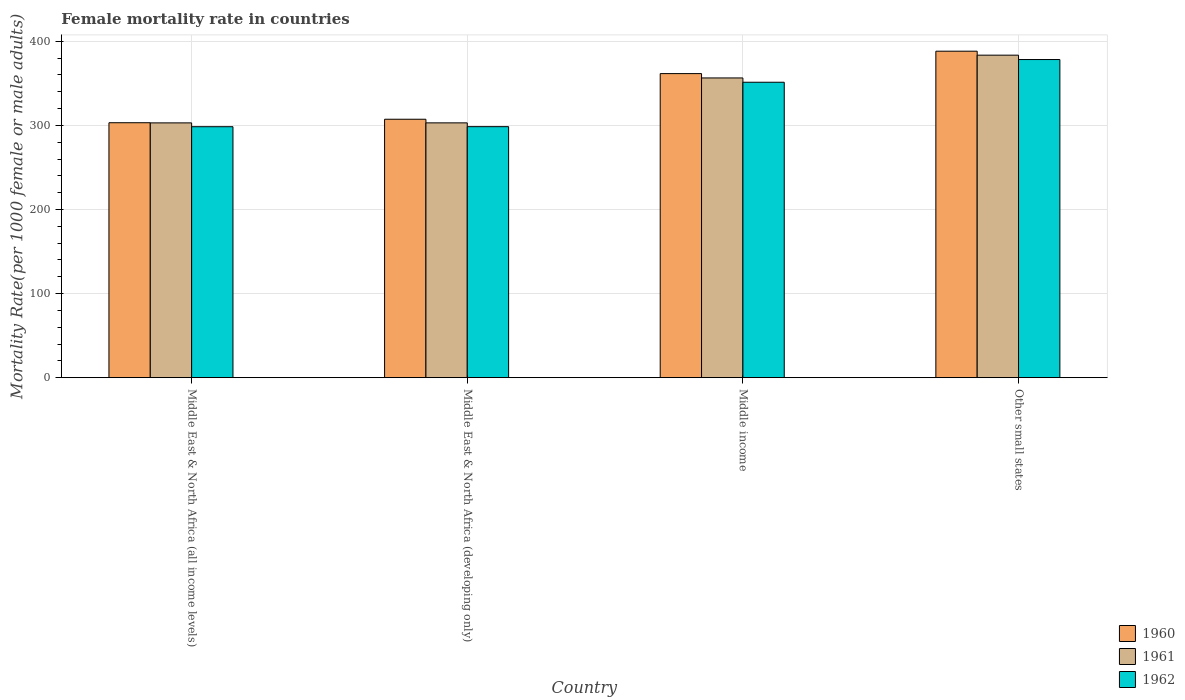How many different coloured bars are there?
Ensure brevity in your answer.  3. Are the number of bars on each tick of the X-axis equal?
Your answer should be very brief. Yes. How many bars are there on the 1st tick from the right?
Provide a short and direct response. 3. What is the label of the 3rd group of bars from the left?
Provide a succinct answer. Middle income. What is the female mortality rate in 1961 in Middle East & North Africa (developing only)?
Make the answer very short. 302.99. Across all countries, what is the maximum female mortality rate in 1961?
Keep it short and to the point. 383.48. Across all countries, what is the minimum female mortality rate in 1960?
Give a very brief answer. 303.15. In which country was the female mortality rate in 1960 maximum?
Your answer should be compact. Other small states. In which country was the female mortality rate in 1960 minimum?
Offer a very short reply. Middle East & North Africa (all income levels). What is the total female mortality rate in 1960 in the graph?
Ensure brevity in your answer.  1360.19. What is the difference between the female mortality rate in 1960 in Middle East & North Africa (developing only) and that in Other small states?
Offer a terse response. -80.92. What is the difference between the female mortality rate in 1961 in Middle income and the female mortality rate in 1962 in Other small states?
Ensure brevity in your answer.  -21.89. What is the average female mortality rate in 1961 per country?
Your answer should be compact. 336.46. What is the difference between the female mortality rate of/in 1961 and female mortality rate of/in 1960 in Middle East & North Africa (developing only)?
Make the answer very short. -4.3. What is the ratio of the female mortality rate in 1960 in Middle East & North Africa (all income levels) to that in Other small states?
Your answer should be compact. 0.78. Is the female mortality rate in 1962 in Middle East & North Africa (developing only) less than that in Other small states?
Your answer should be very brief. Yes. Is the difference between the female mortality rate in 1961 in Middle East & North Africa (developing only) and Other small states greater than the difference between the female mortality rate in 1960 in Middle East & North Africa (developing only) and Other small states?
Ensure brevity in your answer.  Yes. What is the difference between the highest and the second highest female mortality rate in 1961?
Provide a short and direct response. 53.41. What is the difference between the highest and the lowest female mortality rate in 1961?
Give a very brief answer. 80.53. Is the sum of the female mortality rate in 1961 in Middle East & North Africa (developing only) and Middle income greater than the maximum female mortality rate in 1960 across all countries?
Offer a very short reply. Yes. What does the 3rd bar from the right in Middle income represents?
Your answer should be compact. 1960. Is it the case that in every country, the sum of the female mortality rate in 1962 and female mortality rate in 1961 is greater than the female mortality rate in 1960?
Ensure brevity in your answer.  Yes. What is the difference between two consecutive major ticks on the Y-axis?
Keep it short and to the point. 100. Does the graph contain any zero values?
Offer a terse response. No. Where does the legend appear in the graph?
Ensure brevity in your answer.  Bottom right. How are the legend labels stacked?
Ensure brevity in your answer.  Vertical. What is the title of the graph?
Your response must be concise. Female mortality rate in countries. What is the label or title of the X-axis?
Make the answer very short. Country. What is the label or title of the Y-axis?
Make the answer very short. Mortality Rate(per 1000 female or male adults). What is the Mortality Rate(per 1000 female or male adults) of 1960 in Middle East & North Africa (all income levels)?
Make the answer very short. 303.15. What is the Mortality Rate(per 1000 female or male adults) in 1961 in Middle East & North Africa (all income levels)?
Your response must be concise. 302.95. What is the Mortality Rate(per 1000 female or male adults) in 1962 in Middle East & North Africa (all income levels)?
Your response must be concise. 298.42. What is the Mortality Rate(per 1000 female or male adults) of 1960 in Middle East & North Africa (developing only)?
Ensure brevity in your answer.  307.28. What is the Mortality Rate(per 1000 female or male adults) in 1961 in Middle East & North Africa (developing only)?
Ensure brevity in your answer.  302.99. What is the Mortality Rate(per 1000 female or male adults) of 1962 in Middle East & North Africa (developing only)?
Your response must be concise. 298.47. What is the Mortality Rate(per 1000 female or male adults) in 1960 in Middle income?
Your answer should be very brief. 361.56. What is the Mortality Rate(per 1000 female or male adults) in 1961 in Middle income?
Give a very brief answer. 356.4. What is the Mortality Rate(per 1000 female or male adults) in 1962 in Middle income?
Keep it short and to the point. 351.28. What is the Mortality Rate(per 1000 female or male adults) of 1960 in Other small states?
Give a very brief answer. 388.2. What is the Mortality Rate(per 1000 female or male adults) of 1961 in Other small states?
Ensure brevity in your answer.  383.48. What is the Mortality Rate(per 1000 female or male adults) in 1962 in Other small states?
Offer a terse response. 378.29. Across all countries, what is the maximum Mortality Rate(per 1000 female or male adults) of 1960?
Your answer should be compact. 388.2. Across all countries, what is the maximum Mortality Rate(per 1000 female or male adults) in 1961?
Offer a very short reply. 383.48. Across all countries, what is the maximum Mortality Rate(per 1000 female or male adults) in 1962?
Offer a terse response. 378.29. Across all countries, what is the minimum Mortality Rate(per 1000 female or male adults) in 1960?
Ensure brevity in your answer.  303.15. Across all countries, what is the minimum Mortality Rate(per 1000 female or male adults) in 1961?
Your response must be concise. 302.95. Across all countries, what is the minimum Mortality Rate(per 1000 female or male adults) in 1962?
Your answer should be compact. 298.42. What is the total Mortality Rate(per 1000 female or male adults) of 1960 in the graph?
Ensure brevity in your answer.  1360.19. What is the total Mortality Rate(per 1000 female or male adults) in 1961 in the graph?
Keep it short and to the point. 1345.83. What is the total Mortality Rate(per 1000 female or male adults) in 1962 in the graph?
Your answer should be compact. 1326.46. What is the difference between the Mortality Rate(per 1000 female or male adults) of 1960 in Middle East & North Africa (all income levels) and that in Middle East & North Africa (developing only)?
Make the answer very short. -4.14. What is the difference between the Mortality Rate(per 1000 female or male adults) in 1961 in Middle East & North Africa (all income levels) and that in Middle East & North Africa (developing only)?
Your answer should be very brief. -0.04. What is the difference between the Mortality Rate(per 1000 female or male adults) in 1962 in Middle East & North Africa (all income levels) and that in Middle East & North Africa (developing only)?
Offer a very short reply. -0.05. What is the difference between the Mortality Rate(per 1000 female or male adults) in 1960 in Middle East & North Africa (all income levels) and that in Middle income?
Your answer should be compact. -58.41. What is the difference between the Mortality Rate(per 1000 female or male adults) in 1961 in Middle East & North Africa (all income levels) and that in Middle income?
Your response must be concise. -53.45. What is the difference between the Mortality Rate(per 1000 female or male adults) in 1962 in Middle East & North Africa (all income levels) and that in Middle income?
Ensure brevity in your answer.  -52.86. What is the difference between the Mortality Rate(per 1000 female or male adults) in 1960 in Middle East & North Africa (all income levels) and that in Other small states?
Provide a succinct answer. -85.06. What is the difference between the Mortality Rate(per 1000 female or male adults) of 1961 in Middle East & North Africa (all income levels) and that in Other small states?
Your response must be concise. -80.53. What is the difference between the Mortality Rate(per 1000 female or male adults) of 1962 in Middle East & North Africa (all income levels) and that in Other small states?
Your response must be concise. -79.87. What is the difference between the Mortality Rate(per 1000 female or male adults) of 1960 in Middle East & North Africa (developing only) and that in Middle income?
Keep it short and to the point. -54.27. What is the difference between the Mortality Rate(per 1000 female or male adults) in 1961 in Middle East & North Africa (developing only) and that in Middle income?
Your answer should be very brief. -53.41. What is the difference between the Mortality Rate(per 1000 female or male adults) in 1962 in Middle East & North Africa (developing only) and that in Middle income?
Ensure brevity in your answer.  -52.81. What is the difference between the Mortality Rate(per 1000 female or male adults) in 1960 in Middle East & North Africa (developing only) and that in Other small states?
Your response must be concise. -80.92. What is the difference between the Mortality Rate(per 1000 female or male adults) in 1961 in Middle East & North Africa (developing only) and that in Other small states?
Make the answer very short. -80.5. What is the difference between the Mortality Rate(per 1000 female or male adults) of 1962 in Middle East & North Africa (developing only) and that in Other small states?
Your response must be concise. -79.82. What is the difference between the Mortality Rate(per 1000 female or male adults) in 1960 in Middle income and that in Other small states?
Give a very brief answer. -26.65. What is the difference between the Mortality Rate(per 1000 female or male adults) of 1961 in Middle income and that in Other small states?
Make the answer very short. -27.08. What is the difference between the Mortality Rate(per 1000 female or male adults) in 1962 in Middle income and that in Other small states?
Offer a terse response. -27.01. What is the difference between the Mortality Rate(per 1000 female or male adults) of 1960 in Middle East & North Africa (all income levels) and the Mortality Rate(per 1000 female or male adults) of 1961 in Middle East & North Africa (developing only)?
Your answer should be very brief. 0.16. What is the difference between the Mortality Rate(per 1000 female or male adults) of 1960 in Middle East & North Africa (all income levels) and the Mortality Rate(per 1000 female or male adults) of 1962 in Middle East & North Africa (developing only)?
Keep it short and to the point. 4.68. What is the difference between the Mortality Rate(per 1000 female or male adults) of 1961 in Middle East & North Africa (all income levels) and the Mortality Rate(per 1000 female or male adults) of 1962 in Middle East & North Africa (developing only)?
Ensure brevity in your answer.  4.48. What is the difference between the Mortality Rate(per 1000 female or male adults) in 1960 in Middle East & North Africa (all income levels) and the Mortality Rate(per 1000 female or male adults) in 1961 in Middle income?
Your answer should be very brief. -53.26. What is the difference between the Mortality Rate(per 1000 female or male adults) in 1960 in Middle East & North Africa (all income levels) and the Mortality Rate(per 1000 female or male adults) in 1962 in Middle income?
Your response must be concise. -48.13. What is the difference between the Mortality Rate(per 1000 female or male adults) in 1961 in Middle East & North Africa (all income levels) and the Mortality Rate(per 1000 female or male adults) in 1962 in Middle income?
Your response must be concise. -48.33. What is the difference between the Mortality Rate(per 1000 female or male adults) of 1960 in Middle East & North Africa (all income levels) and the Mortality Rate(per 1000 female or male adults) of 1961 in Other small states?
Ensure brevity in your answer.  -80.34. What is the difference between the Mortality Rate(per 1000 female or male adults) of 1960 in Middle East & North Africa (all income levels) and the Mortality Rate(per 1000 female or male adults) of 1962 in Other small states?
Keep it short and to the point. -75.14. What is the difference between the Mortality Rate(per 1000 female or male adults) of 1961 in Middle East & North Africa (all income levels) and the Mortality Rate(per 1000 female or male adults) of 1962 in Other small states?
Your answer should be compact. -75.34. What is the difference between the Mortality Rate(per 1000 female or male adults) in 1960 in Middle East & North Africa (developing only) and the Mortality Rate(per 1000 female or male adults) in 1961 in Middle income?
Your answer should be compact. -49.12. What is the difference between the Mortality Rate(per 1000 female or male adults) in 1960 in Middle East & North Africa (developing only) and the Mortality Rate(per 1000 female or male adults) in 1962 in Middle income?
Give a very brief answer. -44. What is the difference between the Mortality Rate(per 1000 female or male adults) in 1961 in Middle East & North Africa (developing only) and the Mortality Rate(per 1000 female or male adults) in 1962 in Middle income?
Provide a succinct answer. -48.29. What is the difference between the Mortality Rate(per 1000 female or male adults) of 1960 in Middle East & North Africa (developing only) and the Mortality Rate(per 1000 female or male adults) of 1961 in Other small states?
Ensure brevity in your answer.  -76.2. What is the difference between the Mortality Rate(per 1000 female or male adults) of 1960 in Middle East & North Africa (developing only) and the Mortality Rate(per 1000 female or male adults) of 1962 in Other small states?
Provide a succinct answer. -71. What is the difference between the Mortality Rate(per 1000 female or male adults) in 1961 in Middle East & North Africa (developing only) and the Mortality Rate(per 1000 female or male adults) in 1962 in Other small states?
Offer a terse response. -75.3. What is the difference between the Mortality Rate(per 1000 female or male adults) of 1960 in Middle income and the Mortality Rate(per 1000 female or male adults) of 1961 in Other small states?
Make the answer very short. -21.93. What is the difference between the Mortality Rate(per 1000 female or male adults) in 1960 in Middle income and the Mortality Rate(per 1000 female or male adults) in 1962 in Other small states?
Your answer should be compact. -16.73. What is the difference between the Mortality Rate(per 1000 female or male adults) in 1961 in Middle income and the Mortality Rate(per 1000 female or male adults) in 1962 in Other small states?
Your answer should be compact. -21.89. What is the average Mortality Rate(per 1000 female or male adults) in 1960 per country?
Make the answer very short. 340.05. What is the average Mortality Rate(per 1000 female or male adults) in 1961 per country?
Your response must be concise. 336.46. What is the average Mortality Rate(per 1000 female or male adults) of 1962 per country?
Ensure brevity in your answer.  331.61. What is the difference between the Mortality Rate(per 1000 female or male adults) in 1960 and Mortality Rate(per 1000 female or male adults) in 1961 in Middle East & North Africa (all income levels)?
Ensure brevity in your answer.  0.19. What is the difference between the Mortality Rate(per 1000 female or male adults) of 1960 and Mortality Rate(per 1000 female or male adults) of 1962 in Middle East & North Africa (all income levels)?
Ensure brevity in your answer.  4.73. What is the difference between the Mortality Rate(per 1000 female or male adults) of 1961 and Mortality Rate(per 1000 female or male adults) of 1962 in Middle East & North Africa (all income levels)?
Offer a terse response. 4.54. What is the difference between the Mortality Rate(per 1000 female or male adults) in 1960 and Mortality Rate(per 1000 female or male adults) in 1961 in Middle East & North Africa (developing only)?
Offer a terse response. 4.3. What is the difference between the Mortality Rate(per 1000 female or male adults) in 1960 and Mortality Rate(per 1000 female or male adults) in 1962 in Middle East & North Africa (developing only)?
Offer a terse response. 8.82. What is the difference between the Mortality Rate(per 1000 female or male adults) in 1961 and Mortality Rate(per 1000 female or male adults) in 1962 in Middle East & North Africa (developing only)?
Provide a short and direct response. 4.52. What is the difference between the Mortality Rate(per 1000 female or male adults) in 1960 and Mortality Rate(per 1000 female or male adults) in 1961 in Middle income?
Offer a terse response. 5.15. What is the difference between the Mortality Rate(per 1000 female or male adults) of 1960 and Mortality Rate(per 1000 female or male adults) of 1962 in Middle income?
Offer a terse response. 10.28. What is the difference between the Mortality Rate(per 1000 female or male adults) of 1961 and Mortality Rate(per 1000 female or male adults) of 1962 in Middle income?
Your response must be concise. 5.12. What is the difference between the Mortality Rate(per 1000 female or male adults) in 1960 and Mortality Rate(per 1000 female or male adults) in 1961 in Other small states?
Provide a succinct answer. 4.72. What is the difference between the Mortality Rate(per 1000 female or male adults) in 1960 and Mortality Rate(per 1000 female or male adults) in 1962 in Other small states?
Provide a short and direct response. 9.91. What is the difference between the Mortality Rate(per 1000 female or male adults) of 1961 and Mortality Rate(per 1000 female or male adults) of 1962 in Other small states?
Ensure brevity in your answer.  5.19. What is the ratio of the Mortality Rate(per 1000 female or male adults) in 1960 in Middle East & North Africa (all income levels) to that in Middle East & North Africa (developing only)?
Provide a succinct answer. 0.99. What is the ratio of the Mortality Rate(per 1000 female or male adults) in 1960 in Middle East & North Africa (all income levels) to that in Middle income?
Keep it short and to the point. 0.84. What is the ratio of the Mortality Rate(per 1000 female or male adults) in 1961 in Middle East & North Africa (all income levels) to that in Middle income?
Your answer should be compact. 0.85. What is the ratio of the Mortality Rate(per 1000 female or male adults) in 1962 in Middle East & North Africa (all income levels) to that in Middle income?
Make the answer very short. 0.85. What is the ratio of the Mortality Rate(per 1000 female or male adults) of 1960 in Middle East & North Africa (all income levels) to that in Other small states?
Keep it short and to the point. 0.78. What is the ratio of the Mortality Rate(per 1000 female or male adults) in 1961 in Middle East & North Africa (all income levels) to that in Other small states?
Your response must be concise. 0.79. What is the ratio of the Mortality Rate(per 1000 female or male adults) of 1962 in Middle East & North Africa (all income levels) to that in Other small states?
Offer a very short reply. 0.79. What is the ratio of the Mortality Rate(per 1000 female or male adults) of 1960 in Middle East & North Africa (developing only) to that in Middle income?
Make the answer very short. 0.85. What is the ratio of the Mortality Rate(per 1000 female or male adults) in 1961 in Middle East & North Africa (developing only) to that in Middle income?
Your answer should be compact. 0.85. What is the ratio of the Mortality Rate(per 1000 female or male adults) of 1962 in Middle East & North Africa (developing only) to that in Middle income?
Provide a succinct answer. 0.85. What is the ratio of the Mortality Rate(per 1000 female or male adults) in 1960 in Middle East & North Africa (developing only) to that in Other small states?
Offer a terse response. 0.79. What is the ratio of the Mortality Rate(per 1000 female or male adults) of 1961 in Middle East & North Africa (developing only) to that in Other small states?
Your answer should be very brief. 0.79. What is the ratio of the Mortality Rate(per 1000 female or male adults) in 1962 in Middle East & North Africa (developing only) to that in Other small states?
Provide a short and direct response. 0.79. What is the ratio of the Mortality Rate(per 1000 female or male adults) in 1960 in Middle income to that in Other small states?
Your answer should be very brief. 0.93. What is the ratio of the Mortality Rate(per 1000 female or male adults) of 1961 in Middle income to that in Other small states?
Your answer should be compact. 0.93. What is the ratio of the Mortality Rate(per 1000 female or male adults) in 1962 in Middle income to that in Other small states?
Your response must be concise. 0.93. What is the difference between the highest and the second highest Mortality Rate(per 1000 female or male adults) in 1960?
Keep it short and to the point. 26.65. What is the difference between the highest and the second highest Mortality Rate(per 1000 female or male adults) in 1961?
Make the answer very short. 27.08. What is the difference between the highest and the second highest Mortality Rate(per 1000 female or male adults) in 1962?
Provide a succinct answer. 27.01. What is the difference between the highest and the lowest Mortality Rate(per 1000 female or male adults) in 1960?
Your response must be concise. 85.06. What is the difference between the highest and the lowest Mortality Rate(per 1000 female or male adults) in 1961?
Your answer should be very brief. 80.53. What is the difference between the highest and the lowest Mortality Rate(per 1000 female or male adults) in 1962?
Make the answer very short. 79.87. 